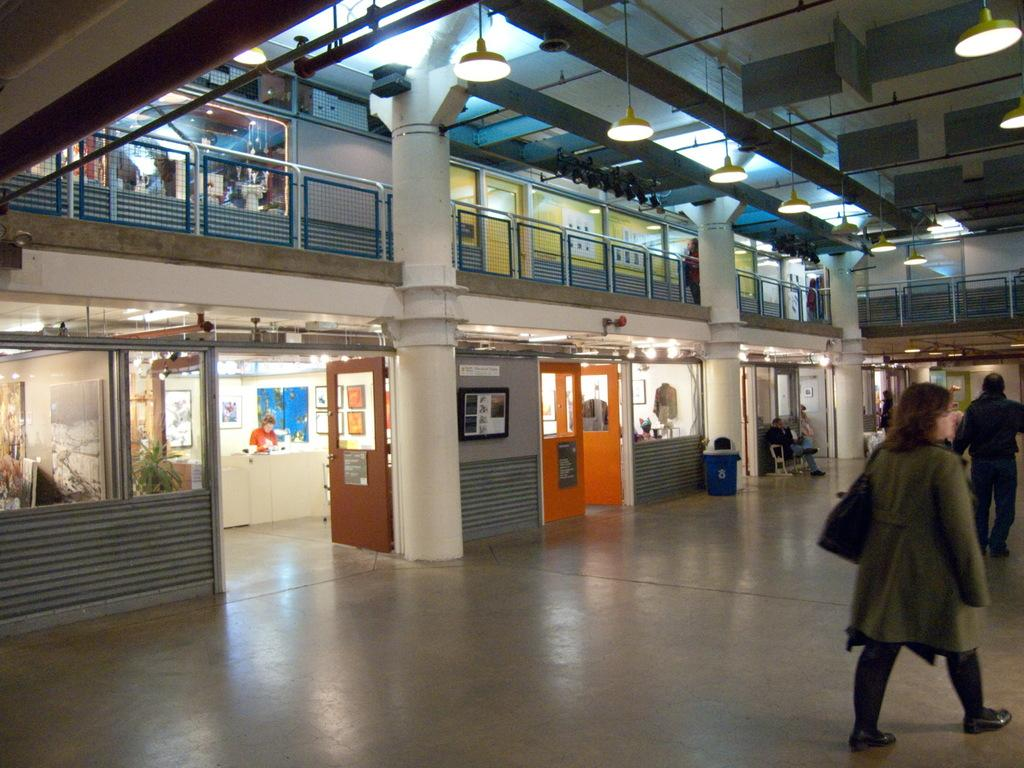What are the two persons in the image doing? The two persons in the image are walking. On what surface are the persons walking? The persons are walking on the floor. Where is the location of the image? The location is inside a building. What can be seen on the left side of the image? There are doors on the left side of the image. How are the doors connected to the building? The doors are attached to a wall. What is visible on the ceiling in the image? There are lights on the ceiling. Can you see an apple on the floor in the image? There is no apple visible on the floor in the image. Is there a trail of dirt behind the persons walking in the image? There is no trail of dirt visible behind the persons walking in the image. 